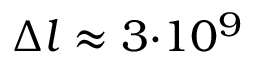<formula> <loc_0><loc_0><loc_500><loc_500>{ \Delta } l \approx 3 { \cdot } 1 0 ^ { 9 }</formula> 